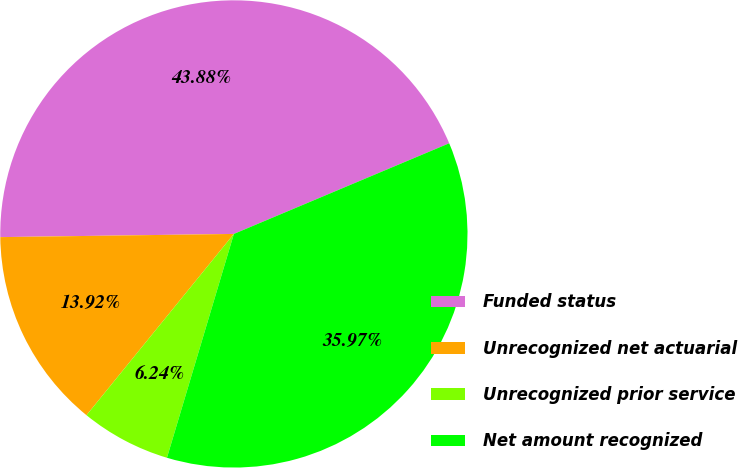<chart> <loc_0><loc_0><loc_500><loc_500><pie_chart><fcel>Funded status<fcel>Unrecognized net actuarial<fcel>Unrecognized prior service<fcel>Net amount recognized<nl><fcel>43.88%<fcel>13.92%<fcel>6.24%<fcel>35.97%<nl></chart> 